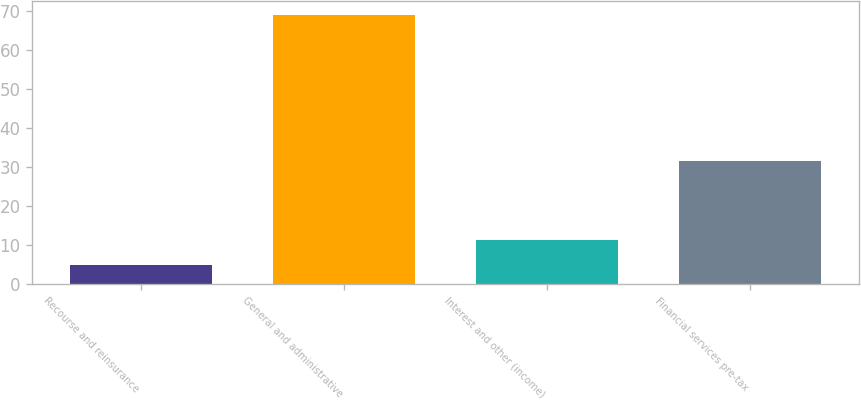Convert chart. <chart><loc_0><loc_0><loc_500><loc_500><bar_chart><fcel>Recourse and reinsurance<fcel>General and administrative<fcel>Interest and other (income)<fcel>Financial services pre-tax<nl><fcel>5<fcel>69<fcel>11.4<fcel>31.6<nl></chart> 